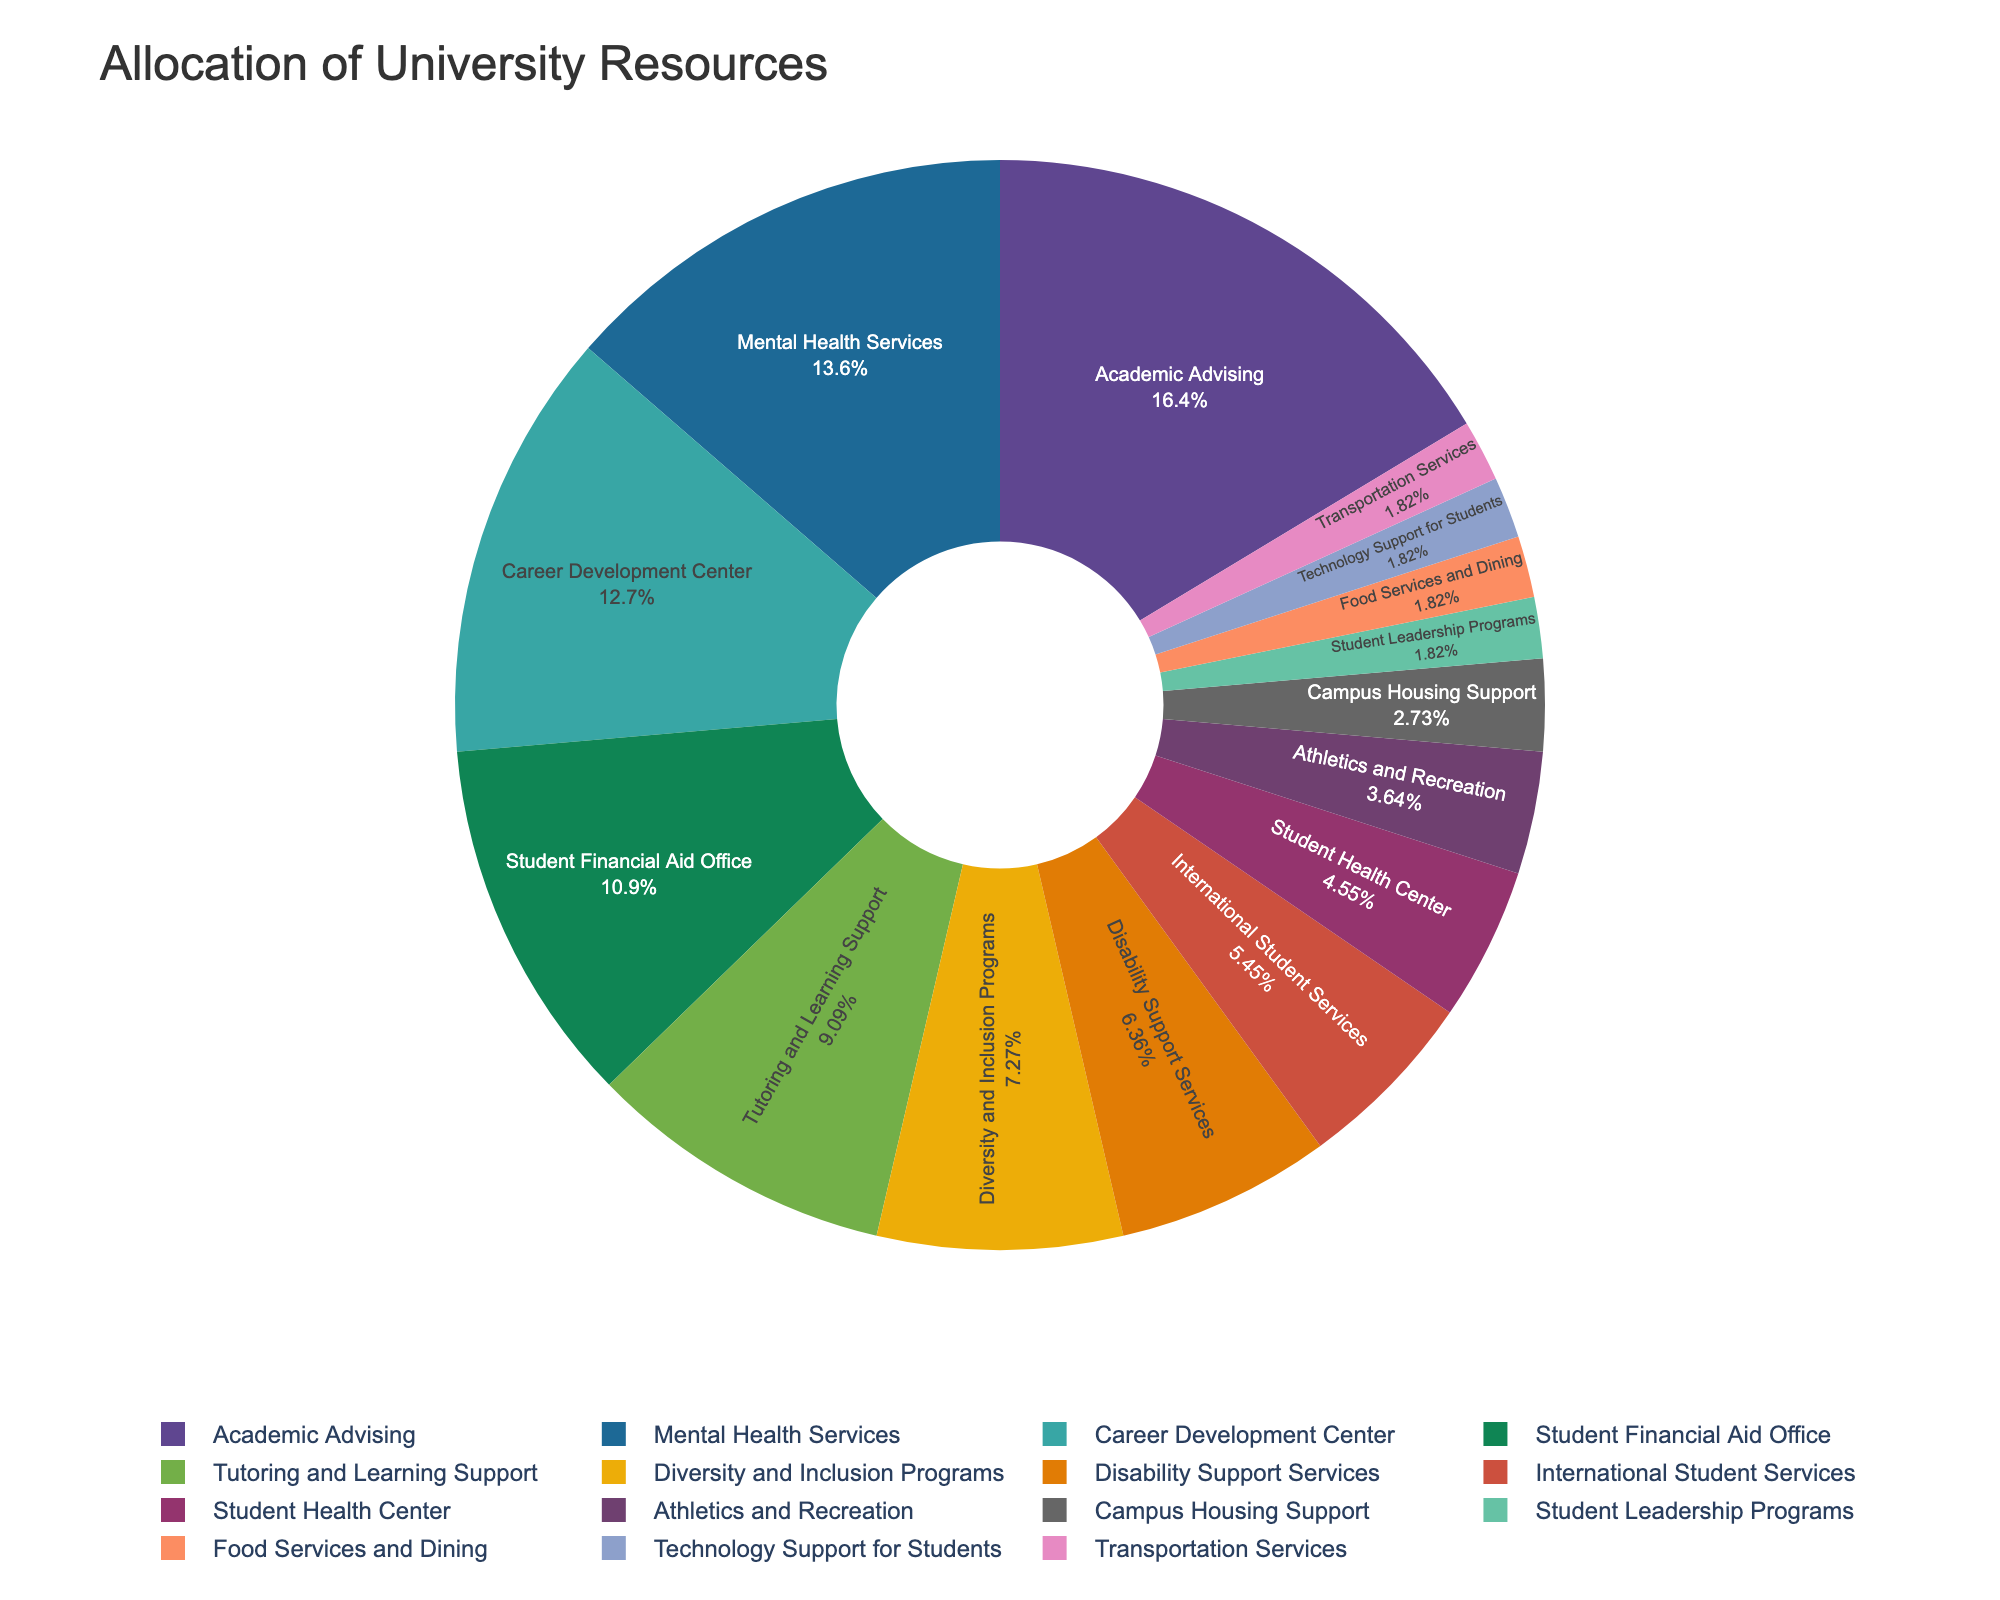What's the total percentage allocated to Academic Advising, Mental Health Services, and Career Development Center? First, find the percentages for Academic Advising (18%), Mental Health Services (15%), and Career Development Center (14%). Add them together: 18 + 15 + 14 = 47.
Answer: 47 Which service has a higher allocation: Disability Support Services or International Student Services? Check the percentages for Disability Support Services (7%) and International Student Services (6%). Since 7% is greater than 6%, Disability Support Services has a higher allocation.
Answer: Disability Support Services Compare the allocation for Student Leadership Programs and Food Services and Dining. Are they the same? Look at the percentages for Student Leadership Programs (2%) and Food Services and Dining (2%). Both have the same allocation.
Answer: Yes Which service receives the lowest allocation of university resources? Identify the service with the smallest percentage, which is Food Services and Dining, Technology Support for Students, and Transportation Services, each with 2%.
Answer: Food Services and Dining, Technology Support for Students, Transportation Services What is the average allocation percentage for student services allocated less than 10%? Identify the services with less than 10%: Tutoring and Learning Support (10%), Diversity and Inclusion Programs (8%), Disability Support Services (7%), International Student Services (6%), Student Health Center (5%), Athletics and Recreation (4%), Campus Housing Support (3%), Student Leadership Programs (2%), Food Services and Dining (2%), Technology Support for Students (2%), Transportation Services (2%). Count the number of these services (11), and add their percentages: 10 + 8 + 7 + 6 + 5 + 4 + 3 + 2 + 2 + 2 + 2 = 51. Calculate the average: 51/11 ≈ 4.6.
Answer: 4.6 What is the difference in allocation between the Mental Health Services and the Student Financial Aid Office? Find the percentages for Mental Health Services (15%) and Student Financial Aid Office (12%). Subtract to find the difference: 15 - 12 = 3.
Answer: 3 Which service categories combined account for over 50% of the university resources? Identify the largest percentages: Academic Advising (18%), Mental Health Services (15%), Career Development Center (14%), and Student Financial Aid Office (12%). Sum these up: 18 + 15 + 14 + 12 = 59, which is over 50%.
Answer: Academic Advising, Mental Health Services, Career Development Center, Student Financial Aid Office What is the combined percentage of services related to health (Mental Health Services and Student Health Center)? Add the percentages of Mental Health Services (15%) and Student Health Center (5%): 15 + 5 = 20.
Answer: 20 Are there more services allocated exactly 2% or fewer than 2%? Check the services with 2% allocation: Student Leadership Programs, Food Services and Dining, Technology Support for Students, and Transportation Services (4 services). There are no services allocated fewer than 2%.
Answer: More services allocated exactly 2% Is Tutoring and Learning Support allocated more or less than Diversity and Inclusion Programs and Disability Support Services combined? Find the percentages for Tutoring and Learning Support (10%), Diversity and Inclusion Programs (8%), and Disability Support Services (7%). Sum the latter two percentages: 8 + 7 = 15. Since 10 is less than 15, Tutoring and Learning Support is allocated less.
Answer: Less 